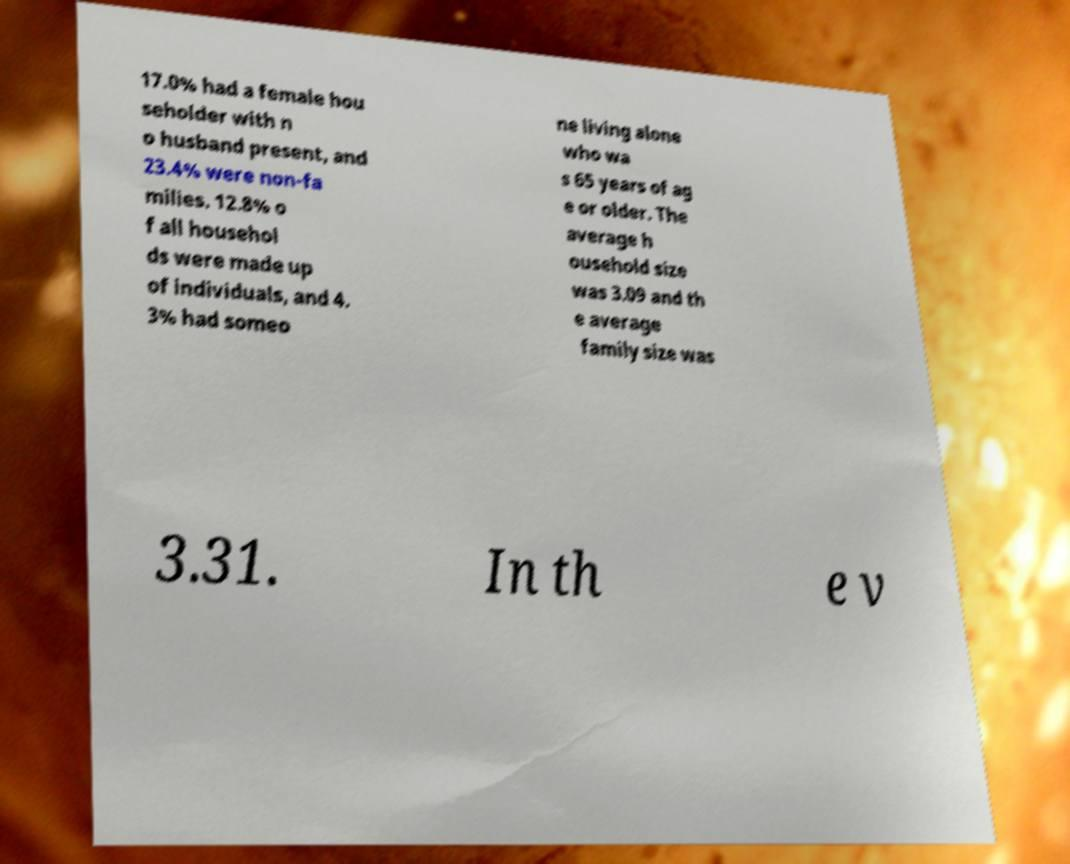Please read and relay the text visible in this image. What does it say? 17.0% had a female hou seholder with n o husband present, and 23.4% were non-fa milies. 12.8% o f all househol ds were made up of individuals, and 4. 3% had someo ne living alone who wa s 65 years of ag e or older. The average h ousehold size was 3.09 and th e average family size was 3.31. In th e v 